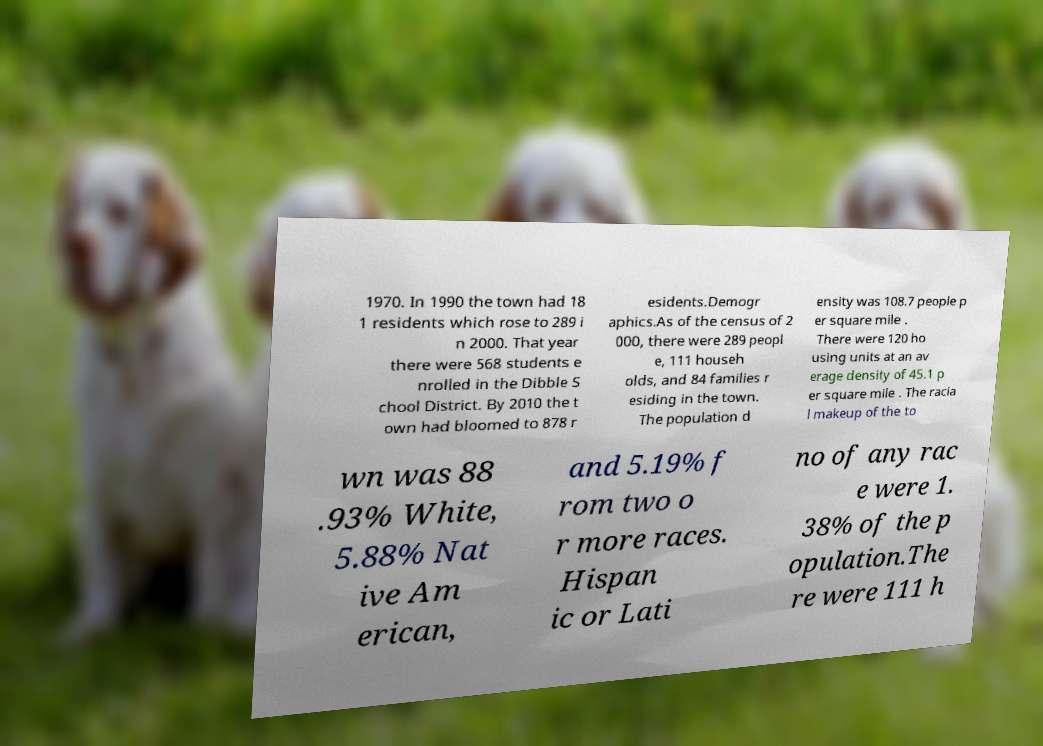I need the written content from this picture converted into text. Can you do that? 1970. In 1990 the town had 18 1 residents which rose to 289 i n 2000. That year there were 568 students e nrolled in the Dibble S chool District. By 2010 the t own had bloomed to 878 r esidents.Demogr aphics.As of the census of 2 000, there were 289 peopl e, 111 househ olds, and 84 families r esiding in the town. The population d ensity was 108.7 people p er square mile . There were 120 ho using units at an av erage density of 45.1 p er square mile . The racia l makeup of the to wn was 88 .93% White, 5.88% Nat ive Am erican, and 5.19% f rom two o r more races. Hispan ic or Lati no of any rac e were 1. 38% of the p opulation.The re were 111 h 